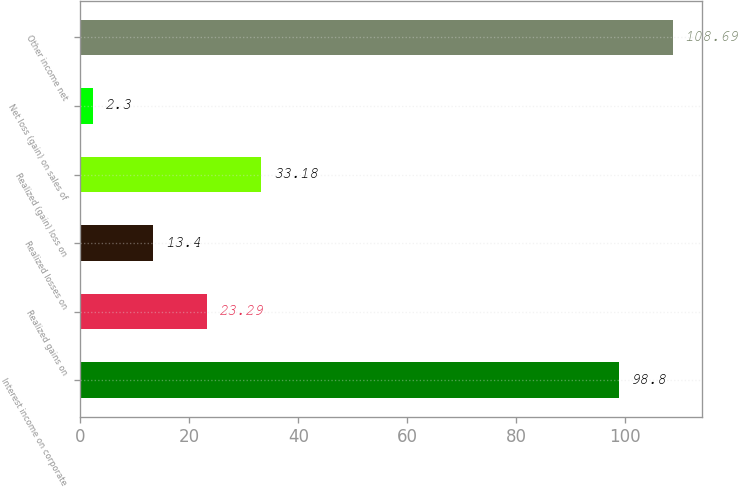Convert chart. <chart><loc_0><loc_0><loc_500><loc_500><bar_chart><fcel>Interest income on corporate<fcel>Realized gains on<fcel>Realized losses on<fcel>Realized (gain) loss on<fcel>Net loss (gain) on sales of<fcel>Other income net<nl><fcel>98.8<fcel>23.29<fcel>13.4<fcel>33.18<fcel>2.3<fcel>108.69<nl></chart> 